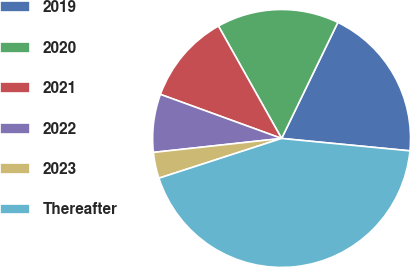Convert chart. <chart><loc_0><loc_0><loc_500><loc_500><pie_chart><fcel>2019<fcel>2020<fcel>2021<fcel>2022<fcel>2023<fcel>Thereafter<nl><fcel>19.35%<fcel>15.33%<fcel>11.3%<fcel>7.28%<fcel>3.26%<fcel>43.48%<nl></chart> 